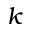Convert formula to latex. <formula><loc_0><loc_0><loc_500><loc_500>k</formula> 